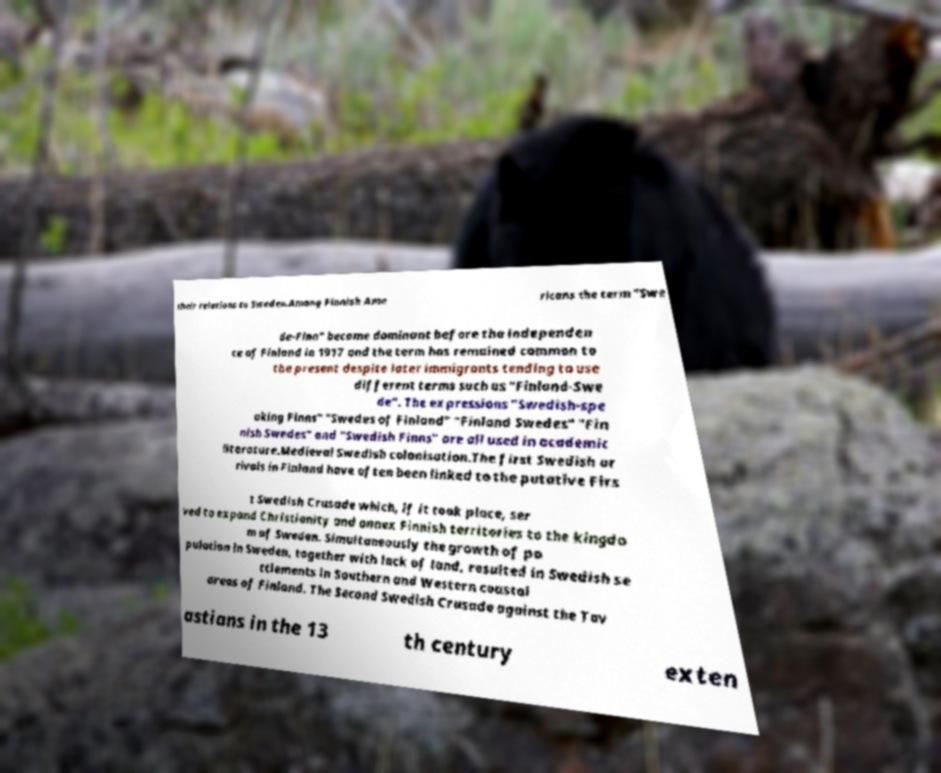Could you extract and type out the text from this image? their relations to Sweden.Among Finnish Ame ricans the term "Swe de-Finn" became dominant before the independen ce of Finland in 1917 and the term has remained common to the present despite later immigrants tending to use different terms such as "Finland-Swe de". The expressions "Swedish-spe aking Finns" "Swedes of Finland" "Finland Swedes" "Fin nish Swedes" and "Swedish Finns" are all used in academic literature.Medieval Swedish colonisation.The first Swedish ar rivals in Finland have often been linked to the putative Firs t Swedish Crusade which, if it took place, ser ved to expand Christianity and annex Finnish territories to the kingdo m of Sweden. Simultaneously the growth of po pulation in Sweden, together with lack of land, resulted in Swedish se ttlements in Southern and Western coastal areas of Finland. The Second Swedish Crusade against the Tav astians in the 13 th century exten 